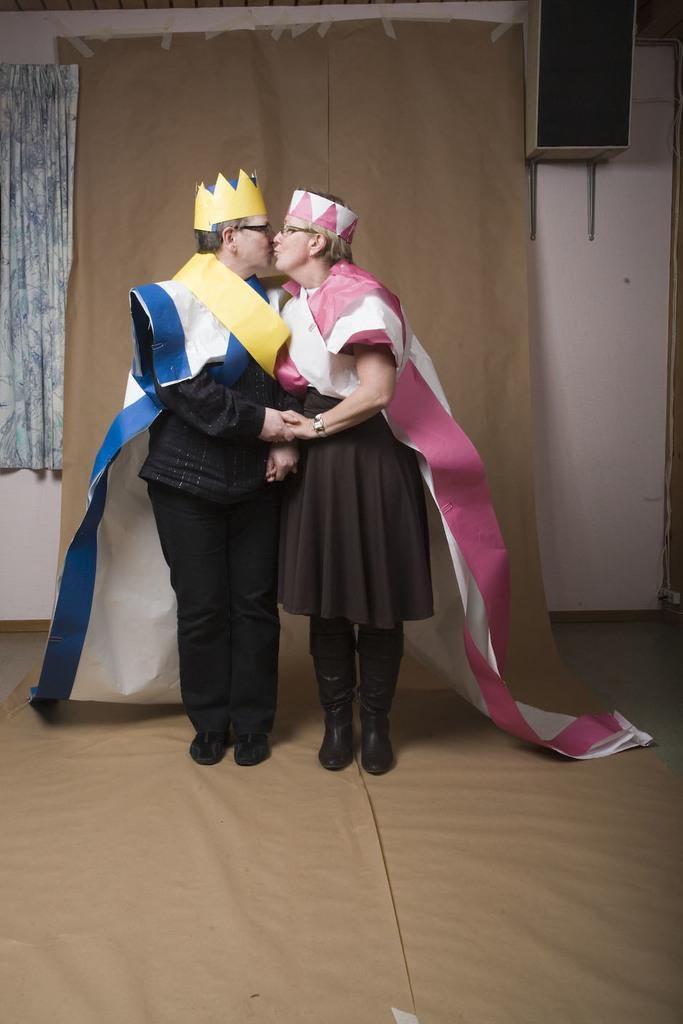Who are the two people in the center of the image? There is a man and a woman in the center of the image. What is the surface they are standing on? The man and woman are standing on the floor. What can be seen in the background of the image? There is a curtain, cloth, a speaker, and a wall in the background of the image. What type of bone is being used as a prop in the image? There is no bone present in the image. How does the cracker contribute to the overall theme of the image? There is no cracker present in the image, so it cannot contribute to the theme. 